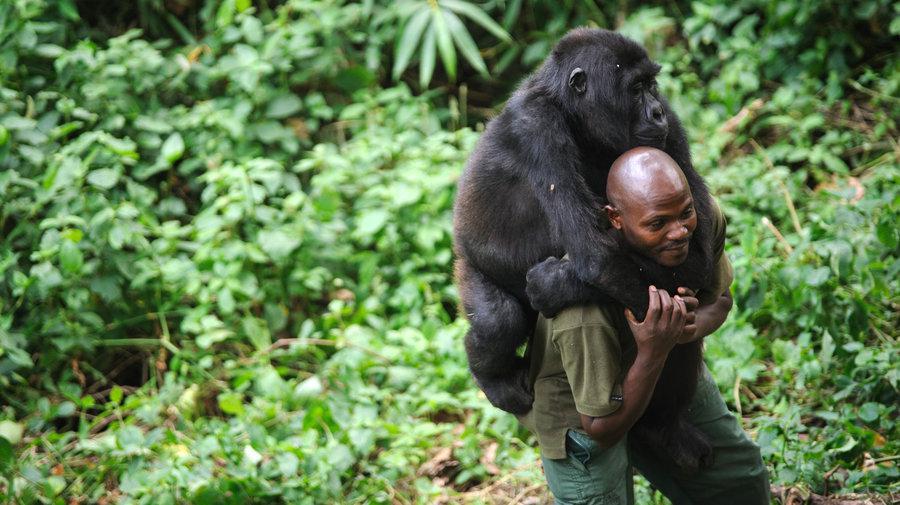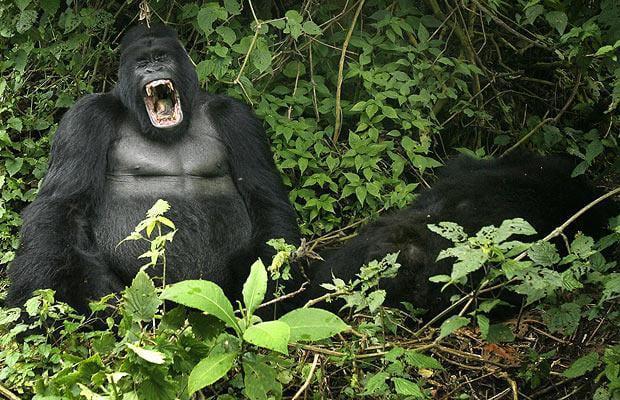The first image is the image on the left, the second image is the image on the right. For the images shown, is this caption "I human is interacting with an ape." true? Answer yes or no. Yes. The first image is the image on the left, the second image is the image on the right. For the images displayed, is the sentence "One image shows a man interacting with a gorilla, with one of them in front of the other but their bodies not facing, and the man is holding on to one of the gorilla's hands." factually correct? Answer yes or no. Yes. 